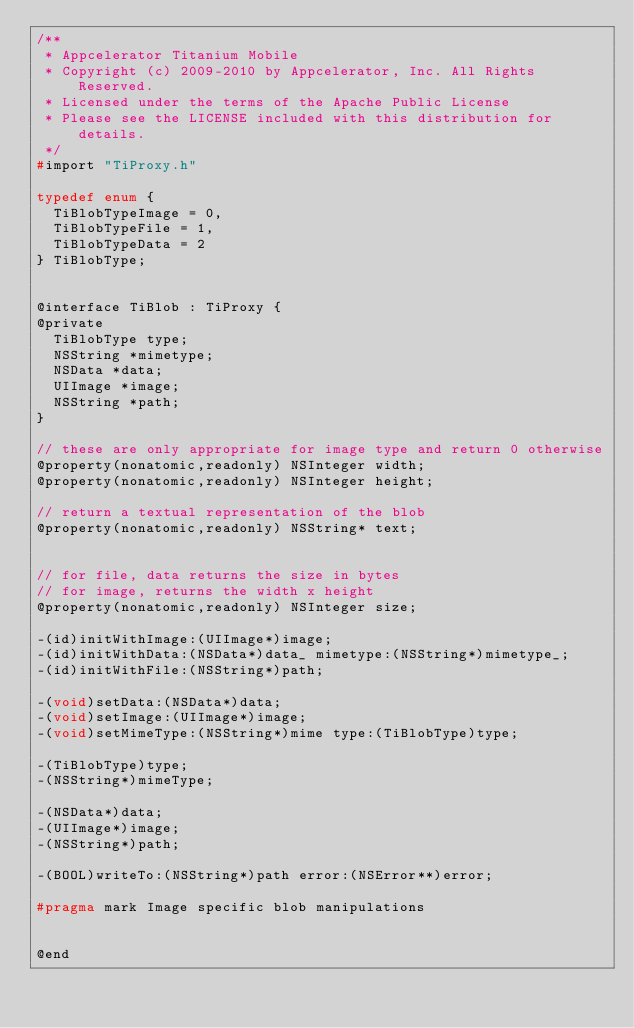Convert code to text. <code><loc_0><loc_0><loc_500><loc_500><_C_>/**
 * Appcelerator Titanium Mobile
 * Copyright (c) 2009-2010 by Appcelerator, Inc. All Rights Reserved.
 * Licensed under the terms of the Apache Public License
 * Please see the LICENSE included with this distribution for details.
 */
#import "TiProxy.h"

typedef enum {
	TiBlobTypeImage = 0,
	TiBlobTypeFile = 1,
	TiBlobTypeData = 2
} TiBlobType;


@interface TiBlob : TiProxy {
@private
	TiBlobType type;
	NSString *mimetype;
	NSData *data;
	UIImage *image;
	NSString *path;
}

// these are only appropriate for image type and return 0 otherwise
@property(nonatomic,readonly) NSInteger width;
@property(nonatomic,readonly) NSInteger height;

// return a textual representation of the blob
@property(nonatomic,readonly) NSString* text;


// for file, data returns the size in bytes
// for image, returns the width x height
@property(nonatomic,readonly) NSInteger size;

-(id)initWithImage:(UIImage*)image;
-(id)initWithData:(NSData*)data_ mimetype:(NSString*)mimetype_;
-(id)initWithFile:(NSString*)path;

-(void)setData:(NSData*)data;
-(void)setImage:(UIImage*)image;
-(void)setMimeType:(NSString*)mime type:(TiBlobType)type;

-(TiBlobType)type;
-(NSString*)mimeType;

-(NSData*)data;
-(UIImage*)image;
-(NSString*)path;

-(BOOL)writeTo:(NSString*)path error:(NSError**)error;

#pragma mark Image specific blob manipulations


@end
</code> 